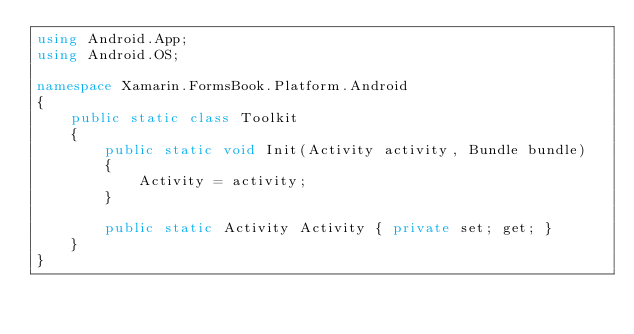Convert code to text. <code><loc_0><loc_0><loc_500><loc_500><_C#_>using Android.App;
using Android.OS;

namespace Xamarin.FormsBook.Platform.Android
{
    public static class Toolkit
    {
        public static void Init(Activity activity, Bundle bundle)
        {
            Activity = activity;
        }

        public static Activity Activity { private set; get; }
    }
}
</code> 